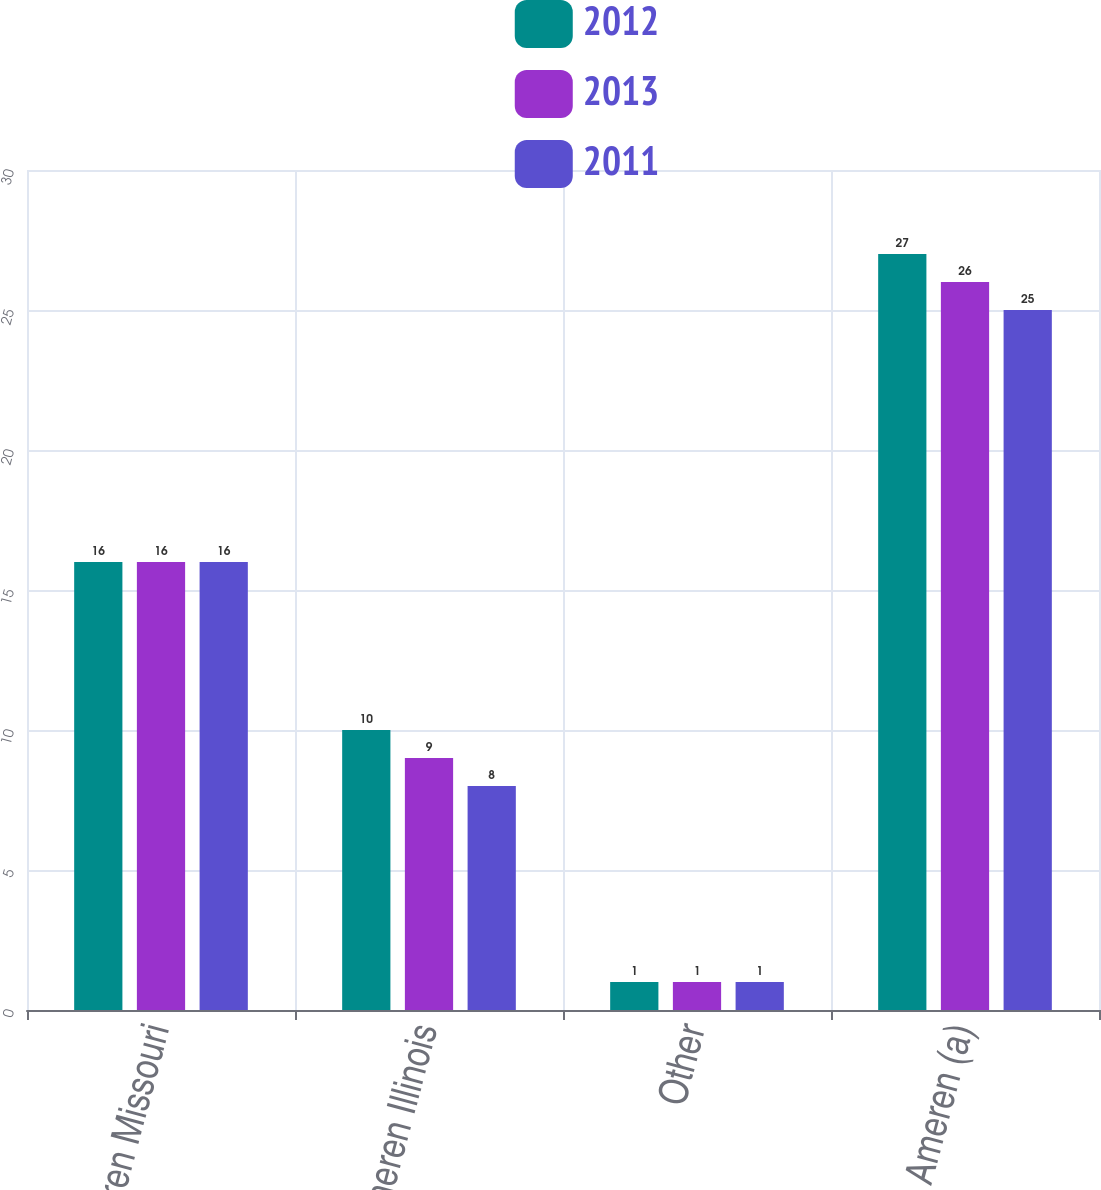<chart> <loc_0><loc_0><loc_500><loc_500><stacked_bar_chart><ecel><fcel>Ameren Missouri<fcel>Ameren Illinois<fcel>Other<fcel>Ameren (a)<nl><fcel>2012<fcel>16<fcel>10<fcel>1<fcel>27<nl><fcel>2013<fcel>16<fcel>9<fcel>1<fcel>26<nl><fcel>2011<fcel>16<fcel>8<fcel>1<fcel>25<nl></chart> 